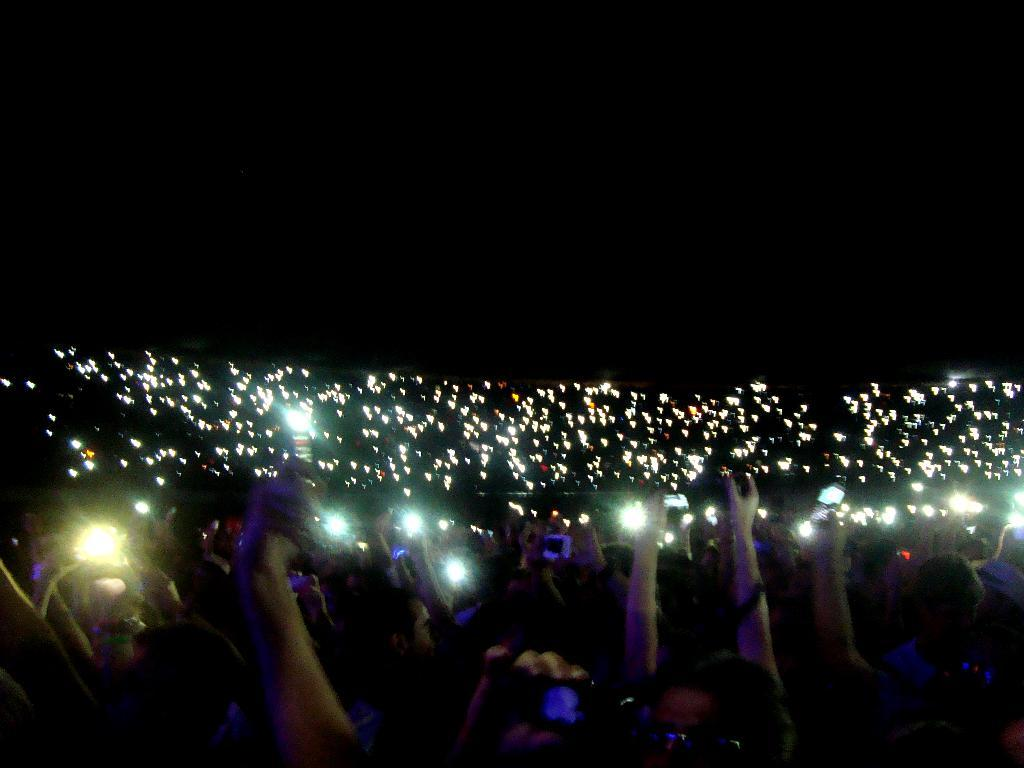Who or what is present in the image? There are people in the image. What are the people doing in the image? The people are showing flashlight on their mobiles. What type of plough is being used by the people in the image? There is no plough present in the image; the people are using flashlights on their mobiles. Where is the crate located in the image? There is no crate present in the image. 